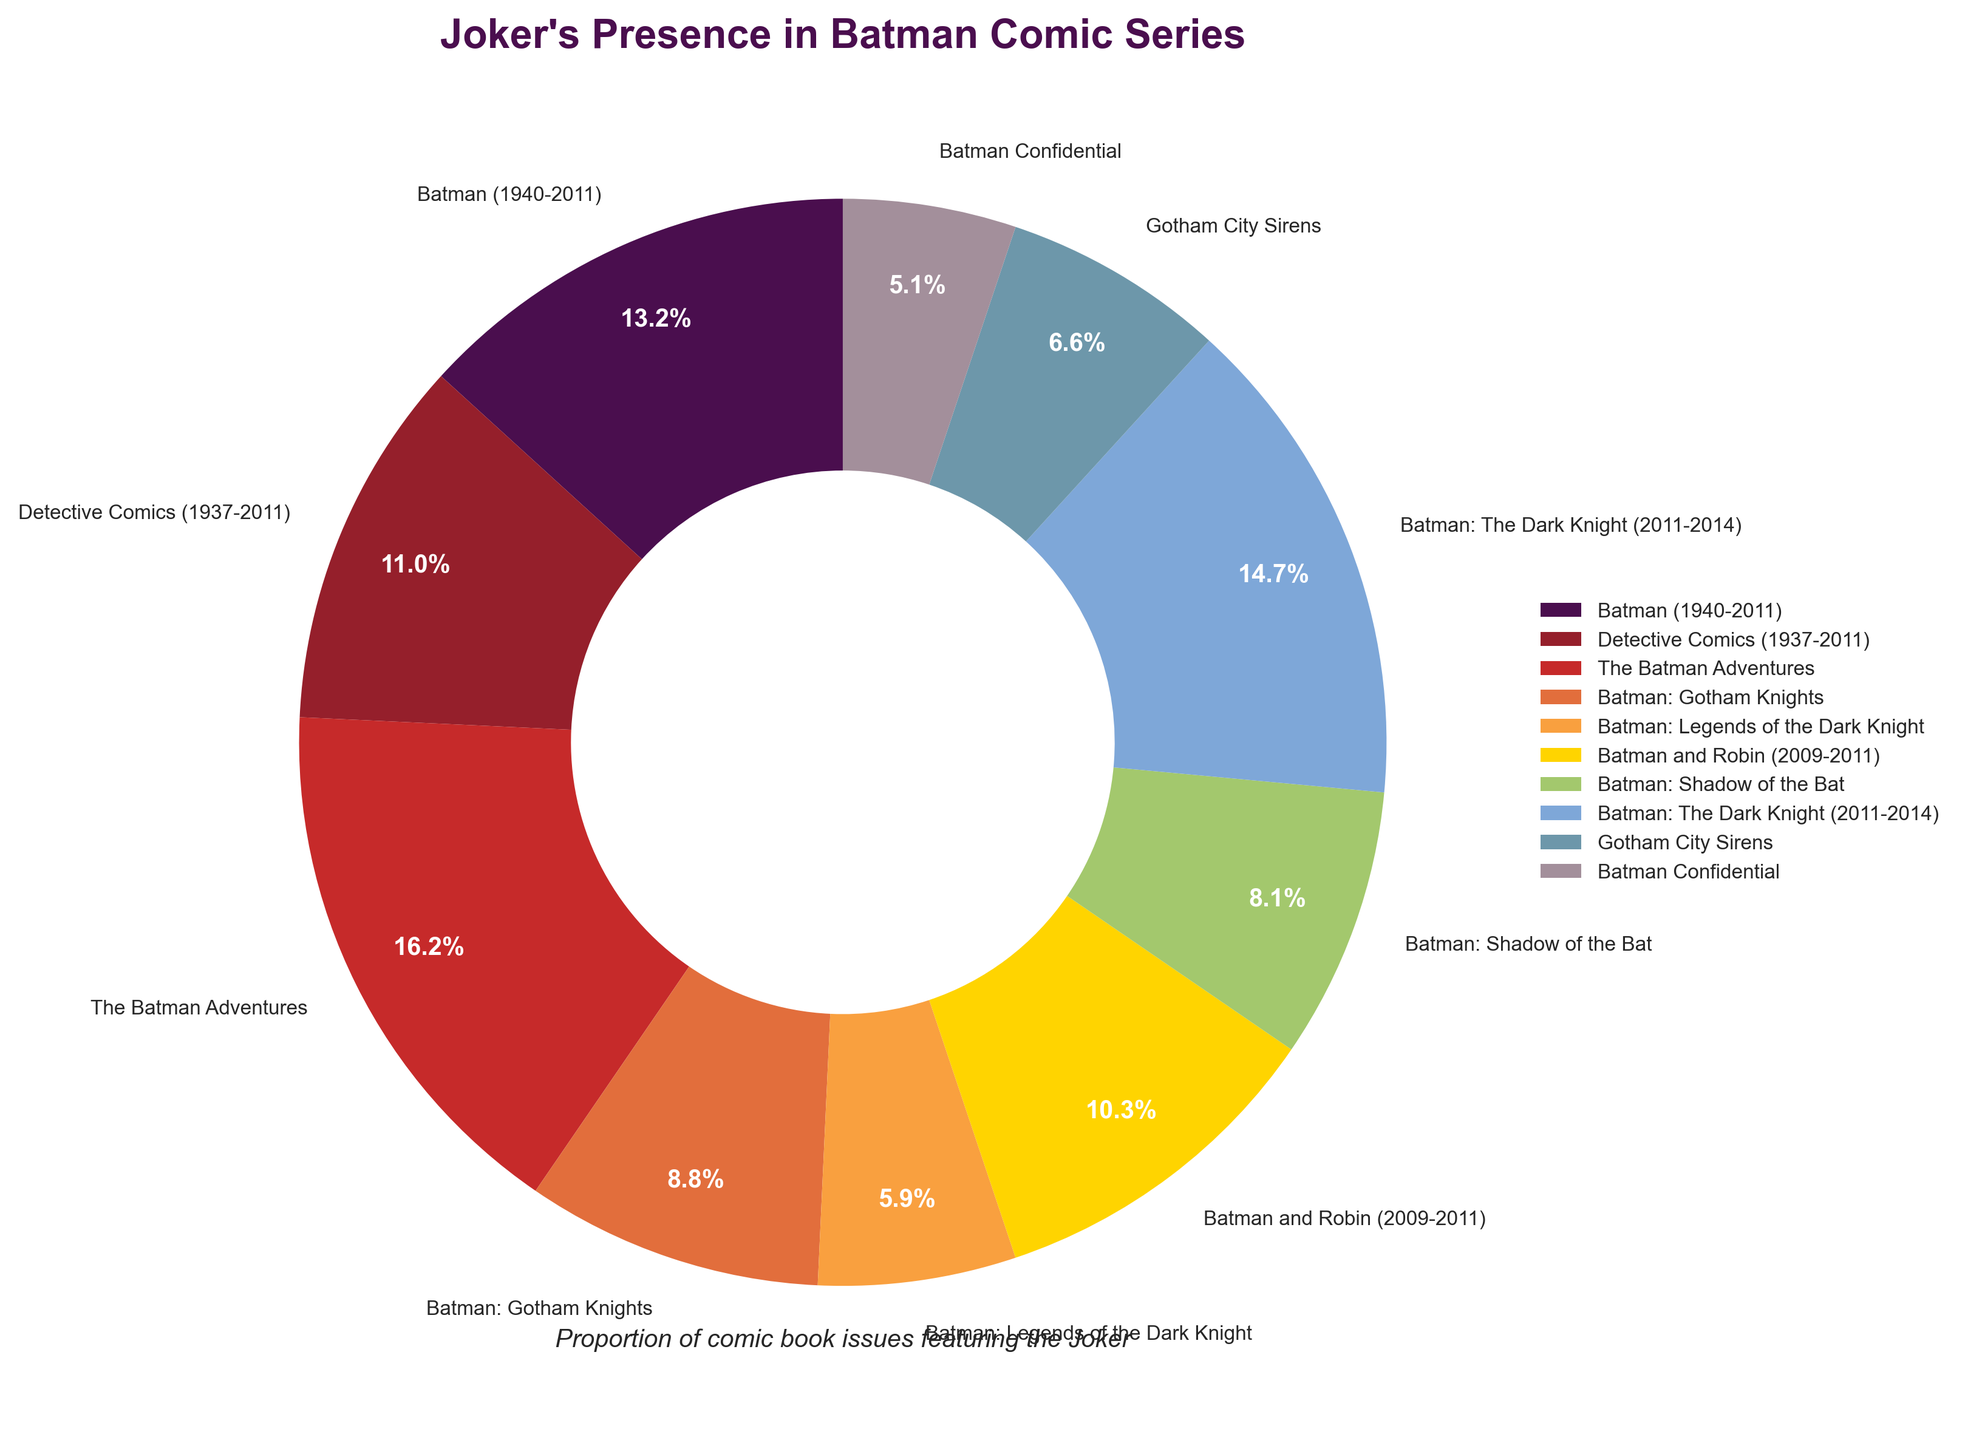Which series has the highest proportion of issues featuring the Joker? The series with the highest proportion can be identified by the largest slice in the pie chart. "The Batman Adventures" has the largest slice.
Answer: The Batman Adventures Which series has the lowest proportion of issues featuring the Joker? The series with the smallest slice in the pie chart represents the lowest proportion. "Batman Confidential" has the smallest slice.
Answer: Batman Confidential How much more proportion does "The Batman Adventures" have compared to "Batman: Legends of the Dark Knight"? The proportion of "The Batman Adventures" is 22% and "Batman: Legends of the Dark Knight" is 8%. The difference is 22% - 8% = 14%.
Answer: 14% Is "Detective Comics (1937-2011)" proportion higher or lower than "Batman: The Dark Knight (2011-2014)"? "Detective Comics (1937-2011)" has a proportion of 15% and "Batman: The Dark Knight (2011-2014)" has 20%. 15% is lower than 20%.
Answer: Lower If we combine the proportions of "Batman: Shadow of the Bat" and "Batman: Gotham Knights," what is the total proportion? "Batman: Shadow of the Bat" is 11% and "Batman: Gotham Knights" is 12%. 11% + 12% = 23%.
Answer: 23% Is there any series with exactly 10% or more than 20% proportion? No slice in the pie chart exactly represents 10%, but there is "The Batman Adventures" with 22% and "Batman: The Dark Knight (2011-2014)" with 20%, which are above 20%.
Answer: Yes Which series share the same color shade, and what are their proportions? Different slices have distinct colors; there are no shared colors between slices as each one is unique.
Answer: None How many series have a proportion greater than or equal to 15%? The series are "Batman (1940-2011)" (18%), "Detective Comics (1937-2011)" (15%), "The Batman Adventures" (22%), and "Batman: The Dark Knight (2011-2014)" (20%). There are 4 such series.
Answer: 4 Which three series have the closest proportions? List them and their proportions. The three series with the closest proportions are "Batman: Legends of the Dark Knight" (8%), "Gotham City Sirens" (9%), and "Batman: Shadow of the Bat" (11%).
Answer: Batman: Legends of the Dark Knight (8%), Gotham City Sirens (9%), Batman: Shadow of the Bat (11%) Which series represent more than 60% when combined? The series needs to be calculated by summing up their proportions: "The Batman Adventures" (22%), "Batman: The Dark Knight (2011-2014)" (20%), and "Batman (1940-2011)" (18%) together contribute 22% + 20% + 18% = 60%. So, these series together represent exactly 60%.
Answer: The Batman Adventures, Batman: The Dark Knight (2011-2014), Batman (1940-2011) 